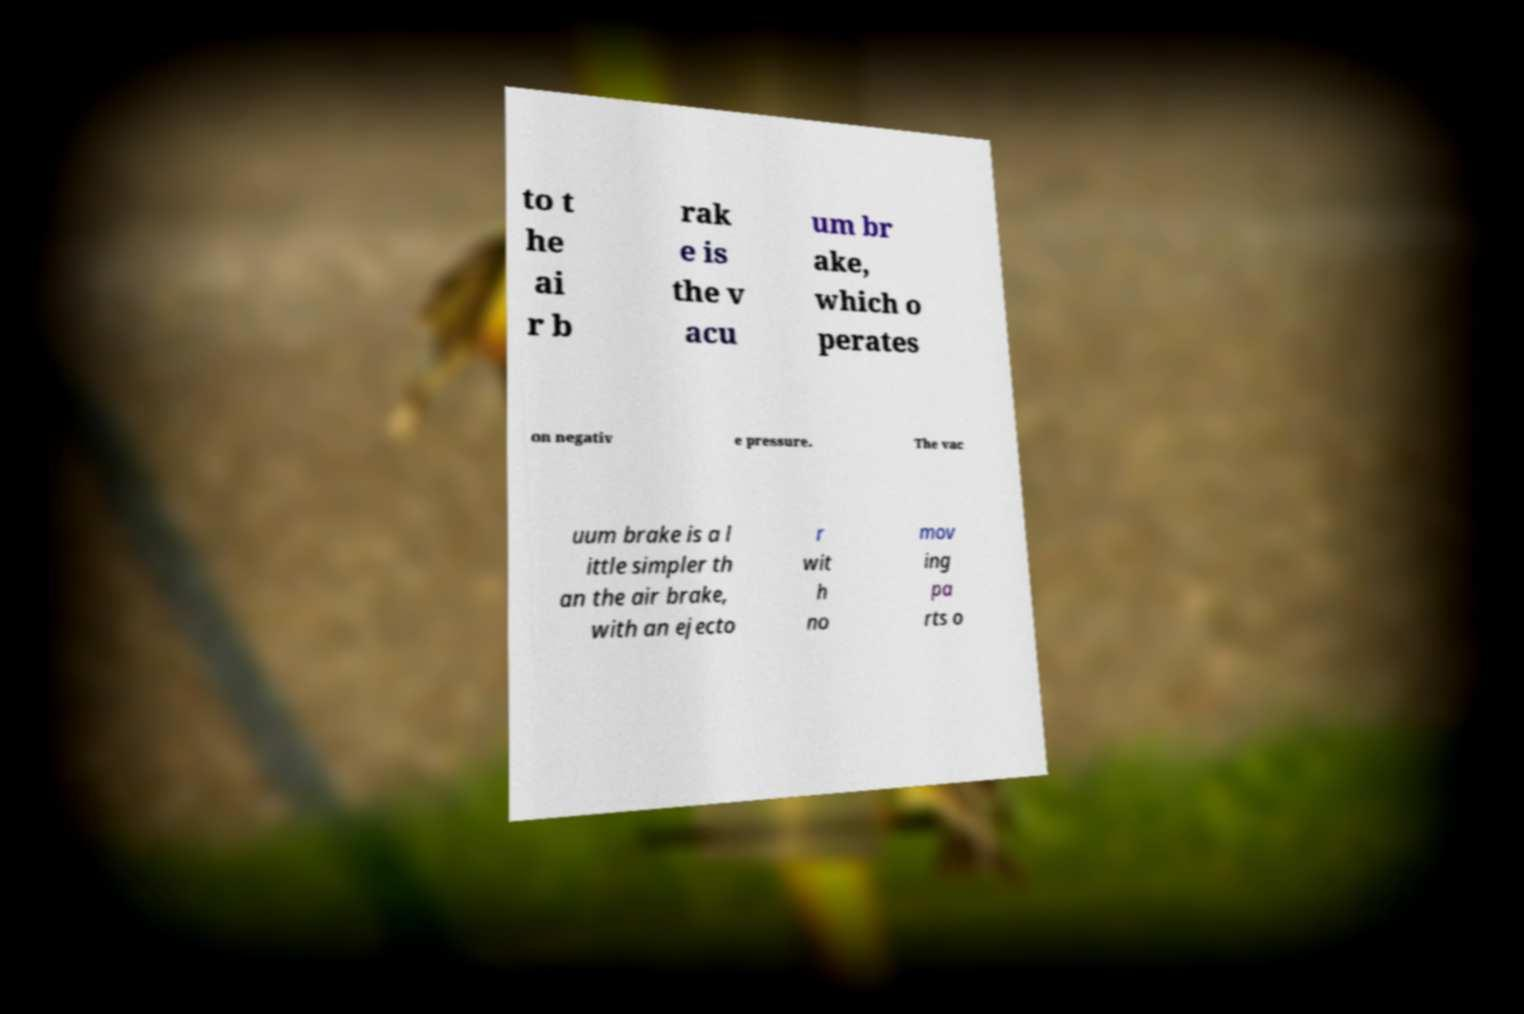There's text embedded in this image that I need extracted. Can you transcribe it verbatim? to t he ai r b rak e is the v acu um br ake, which o perates on negativ e pressure. The vac uum brake is a l ittle simpler th an the air brake, with an ejecto r wit h no mov ing pa rts o 